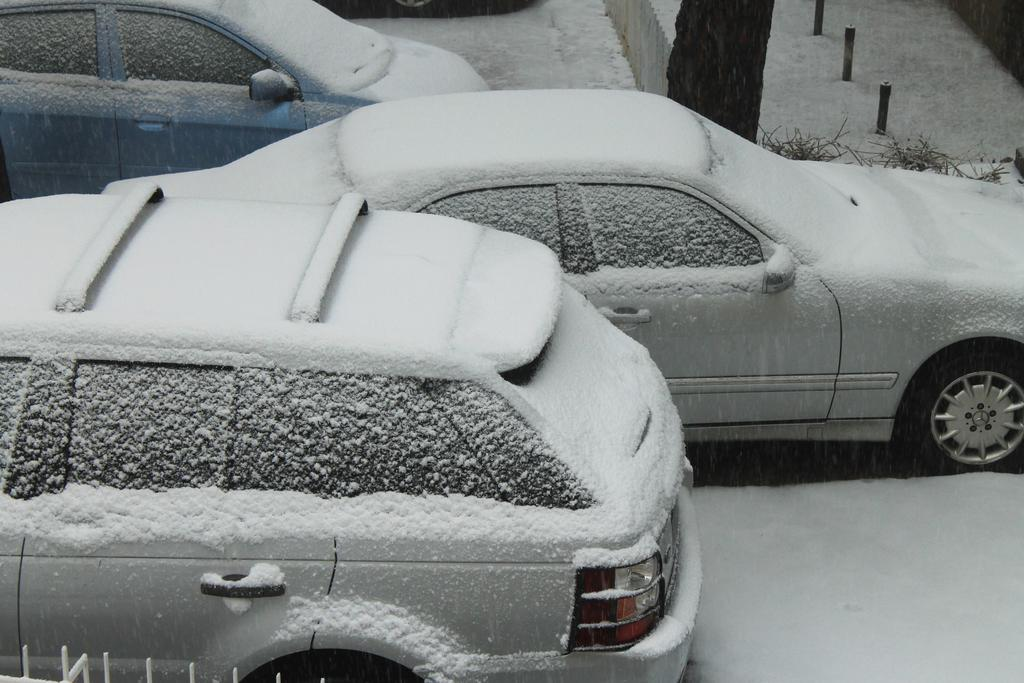Where was the image taken? The image is taken outdoors. What can be seen on the ground in the image? There are cars parked on the ground. How are the cars affected by the weather in the image? The cars are covered with snow. What type of natural element is visible in the image? There is a tree visible at the top of the image. Can you see any deer joining the cars in the image? There are no deer present in the image, and they are not interacting with the cars. 